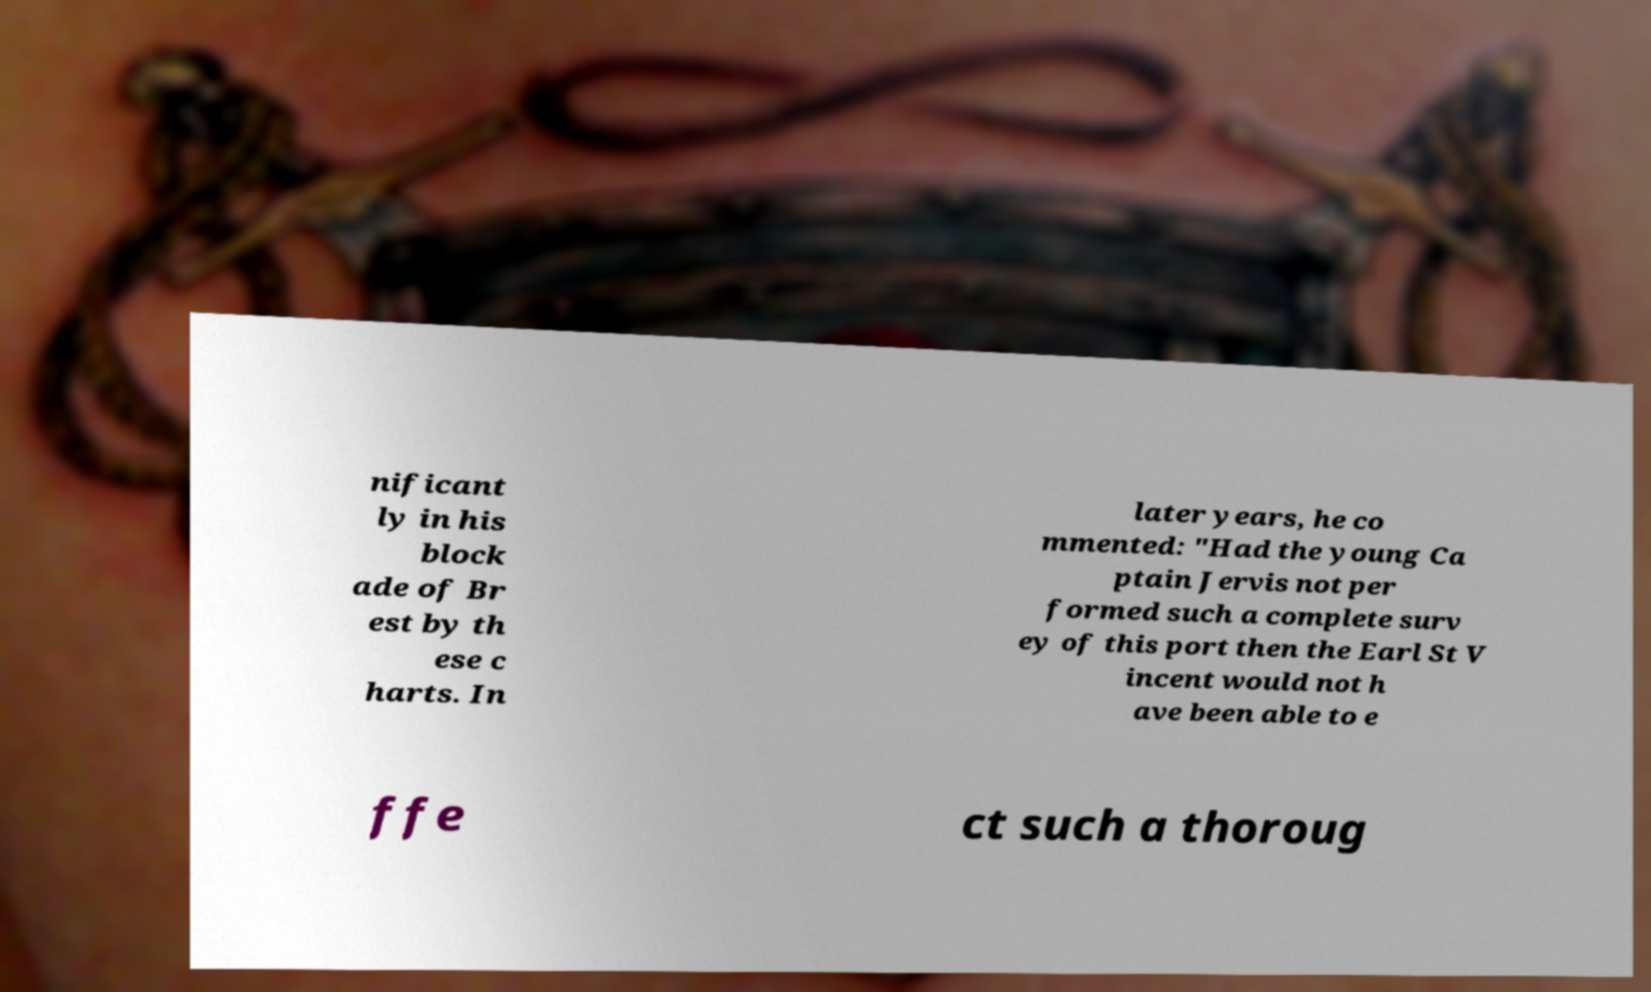Can you accurately transcribe the text from the provided image for me? nificant ly in his block ade of Br est by th ese c harts. In later years, he co mmented: "Had the young Ca ptain Jervis not per formed such a complete surv ey of this port then the Earl St V incent would not h ave been able to e ffe ct such a thoroug 